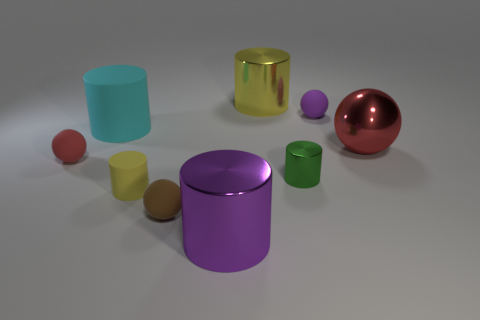What is the size of the matte object that is the same color as the large ball?
Ensure brevity in your answer.  Small. What color is the rubber sphere right of the large purple metal cylinder?
Provide a short and direct response. Purple. Is the shape of the purple rubber thing the same as the red thing on the right side of the small yellow matte cylinder?
Provide a short and direct response. Yes. Are there any small rubber objects of the same color as the large matte cylinder?
Your answer should be compact. No. What is the size of the purple cylinder that is made of the same material as the tiny green cylinder?
Make the answer very short. Large. Is the color of the small shiny object the same as the metal ball?
Offer a very short reply. No. Is the shape of the matte thing that is to the right of the purple cylinder the same as  the green object?
Give a very brief answer. No. What number of brown matte spheres are the same size as the purple metal object?
Your answer should be very brief. 0. What is the shape of the small matte object that is the same color as the metallic sphere?
Make the answer very short. Sphere. There is a small rubber object that is to the left of the big cyan rubber object; are there any large cyan rubber cylinders left of it?
Ensure brevity in your answer.  No. 